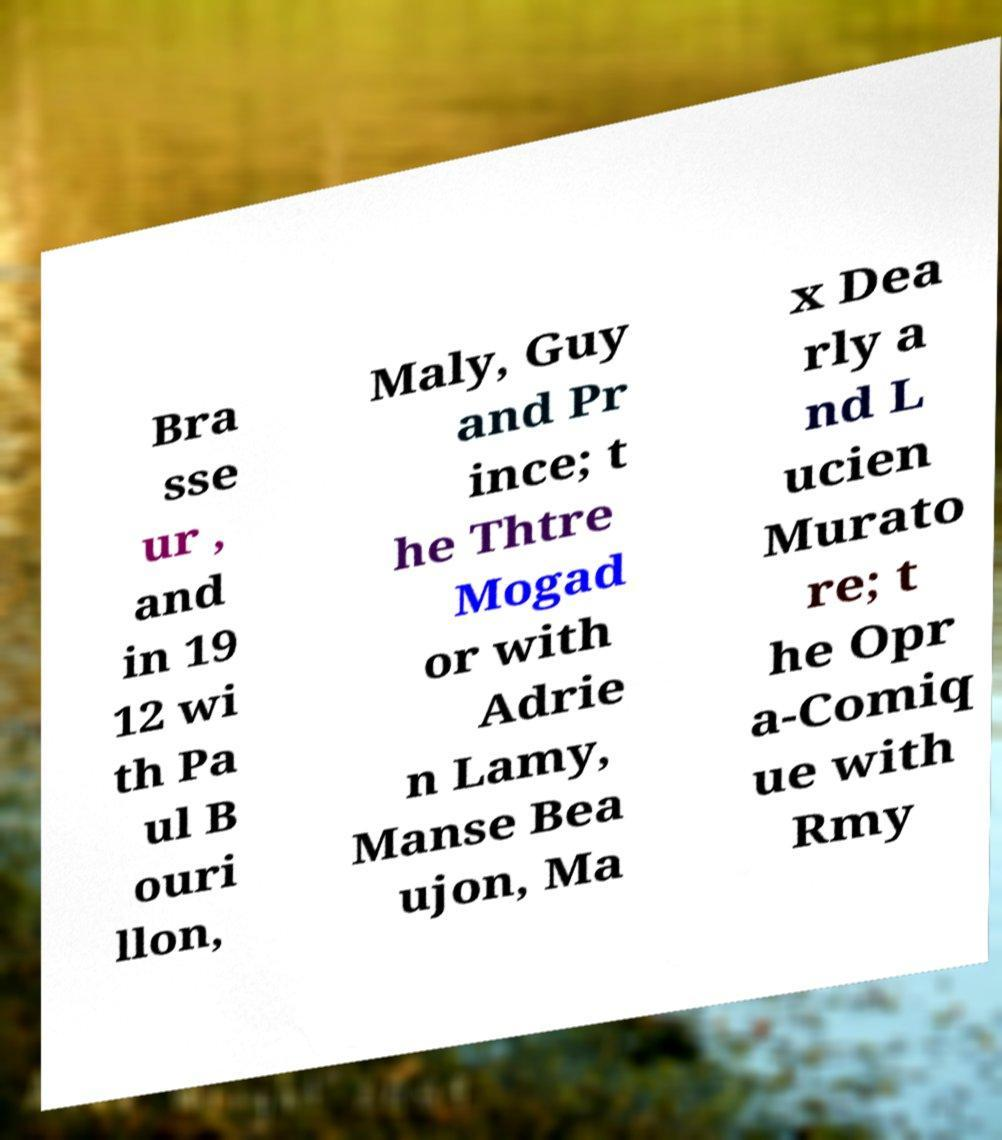Can you accurately transcribe the text from the provided image for me? Bra sse ur , and in 19 12 wi th Pa ul B ouri llon, Maly, Guy and Pr ince; t he Thtre Mogad or with Adrie n Lamy, Manse Bea ujon, Ma x Dea rly a nd L ucien Murato re; t he Opr a-Comiq ue with Rmy 